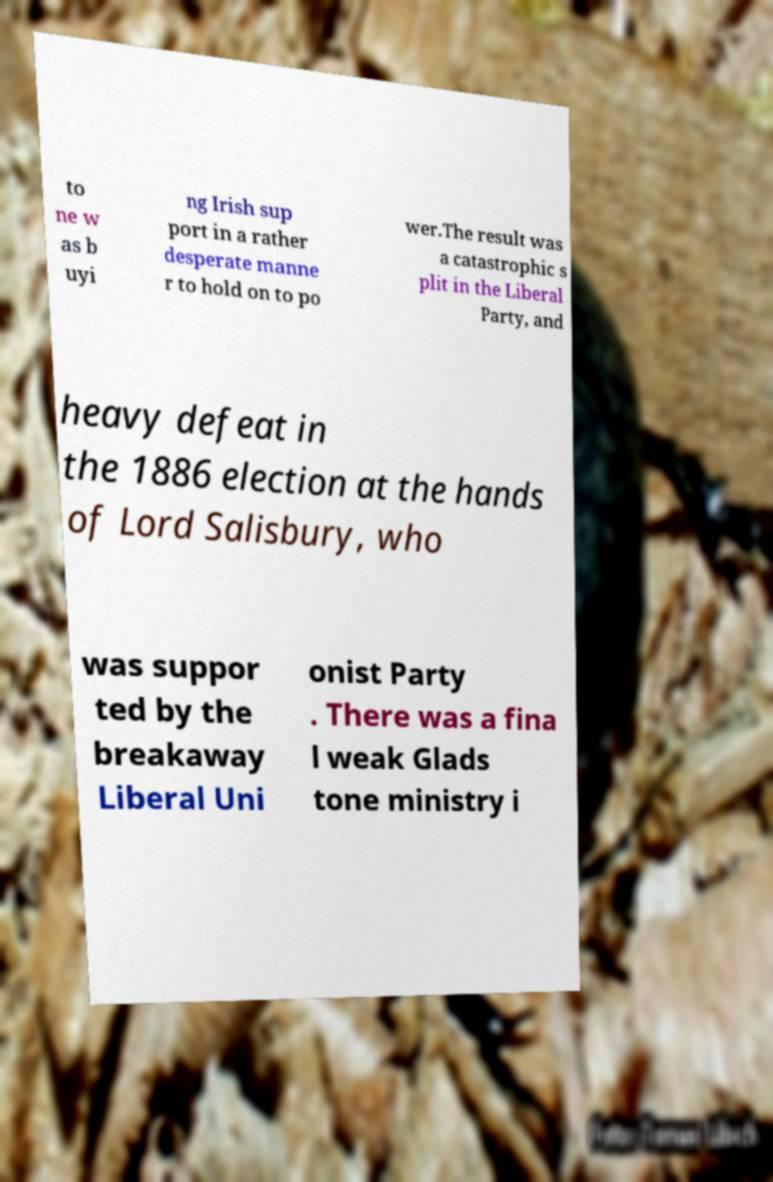Please read and relay the text visible in this image. What does it say? to ne w as b uyi ng Irish sup port in a rather desperate manne r to hold on to po wer.The result was a catastrophic s plit in the Liberal Party, and heavy defeat in the 1886 election at the hands of Lord Salisbury, who was suppor ted by the breakaway Liberal Uni onist Party . There was a fina l weak Glads tone ministry i 